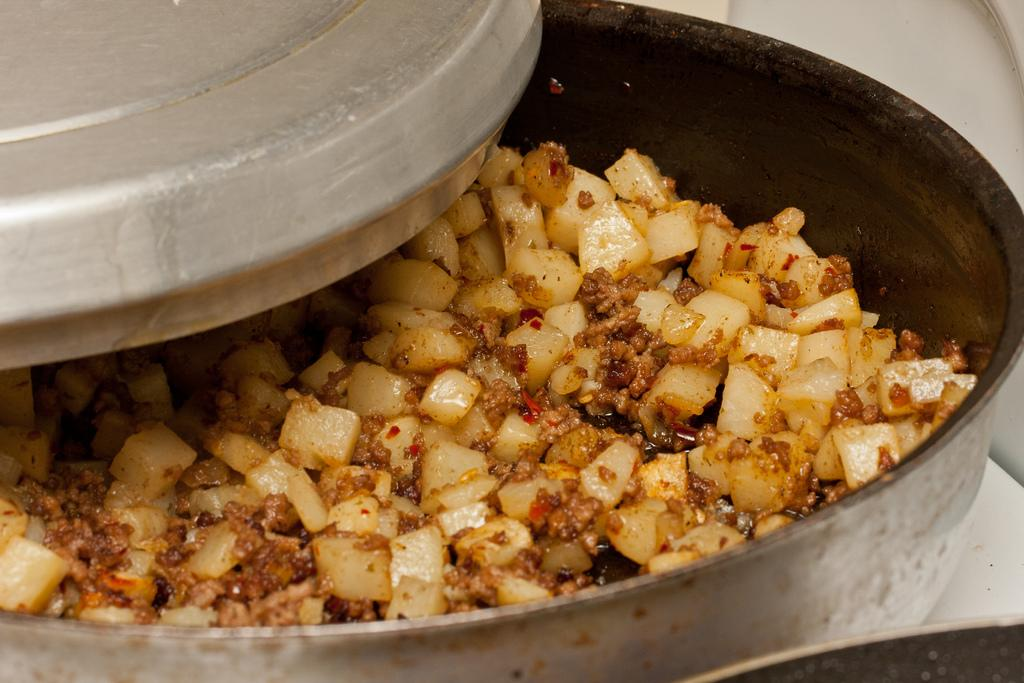What can be seen in the image related to food? There is food in the image. Can you describe the dish containing the food? The dish containing the food is partially opened. What type of bun is being served on the railway in the image? There is no bun or railway present in the image; it only features food in a partially opened dish. 